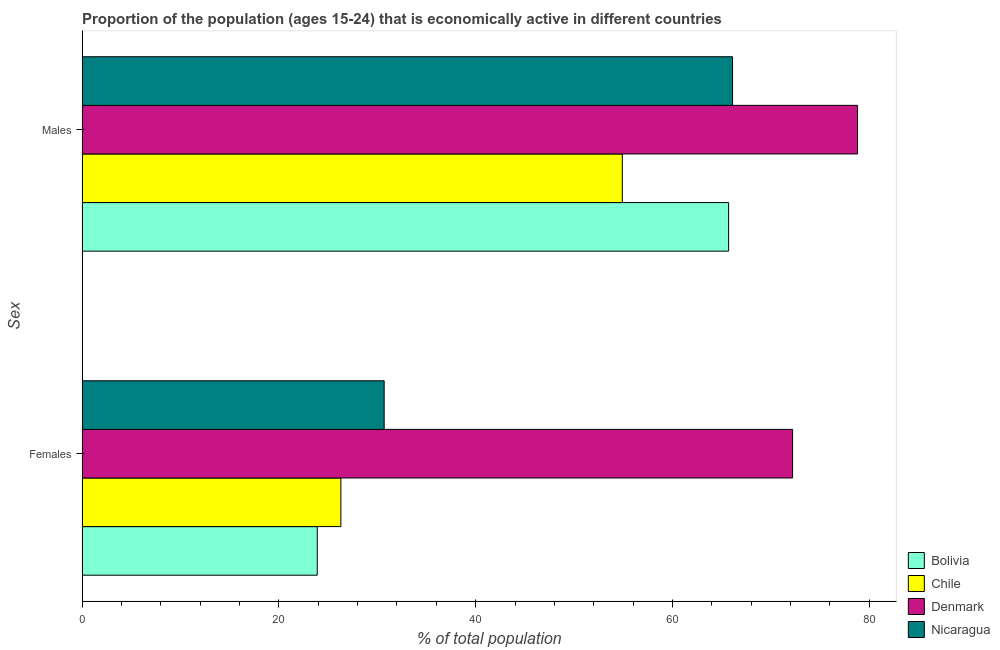How many different coloured bars are there?
Make the answer very short. 4. How many bars are there on the 2nd tick from the bottom?
Give a very brief answer. 4. What is the label of the 2nd group of bars from the top?
Give a very brief answer. Females. What is the percentage of economically active female population in Bolivia?
Your response must be concise. 23.9. Across all countries, what is the maximum percentage of economically active male population?
Your answer should be compact. 78.8. Across all countries, what is the minimum percentage of economically active female population?
Provide a succinct answer. 23.9. In which country was the percentage of economically active male population minimum?
Your answer should be compact. Chile. What is the total percentage of economically active female population in the graph?
Give a very brief answer. 153.1. What is the difference between the percentage of economically active male population in Denmark and that in Bolivia?
Offer a very short reply. 13.1. What is the difference between the percentage of economically active male population in Chile and the percentage of economically active female population in Nicaragua?
Your answer should be compact. 24.2. What is the average percentage of economically active female population per country?
Provide a succinct answer. 38.27. What is the difference between the percentage of economically active female population and percentage of economically active male population in Nicaragua?
Your answer should be compact. -35.4. In how many countries, is the percentage of economically active female population greater than 16 %?
Your answer should be very brief. 4. What is the ratio of the percentage of economically active female population in Bolivia to that in Nicaragua?
Make the answer very short. 0.78. In how many countries, is the percentage of economically active female population greater than the average percentage of economically active female population taken over all countries?
Give a very brief answer. 1. What does the 1st bar from the top in Females represents?
Your answer should be very brief. Nicaragua. Are all the bars in the graph horizontal?
Provide a short and direct response. Yes. How many countries are there in the graph?
Keep it short and to the point. 4. What is the difference between two consecutive major ticks on the X-axis?
Provide a succinct answer. 20. Are the values on the major ticks of X-axis written in scientific E-notation?
Offer a very short reply. No. Does the graph contain any zero values?
Give a very brief answer. No. Does the graph contain grids?
Make the answer very short. No. How are the legend labels stacked?
Your answer should be compact. Vertical. What is the title of the graph?
Offer a very short reply. Proportion of the population (ages 15-24) that is economically active in different countries. What is the label or title of the X-axis?
Give a very brief answer. % of total population. What is the label or title of the Y-axis?
Your response must be concise. Sex. What is the % of total population in Bolivia in Females?
Offer a very short reply. 23.9. What is the % of total population in Chile in Females?
Offer a very short reply. 26.3. What is the % of total population in Denmark in Females?
Keep it short and to the point. 72.2. What is the % of total population of Nicaragua in Females?
Keep it short and to the point. 30.7. What is the % of total population in Bolivia in Males?
Provide a succinct answer. 65.7. What is the % of total population of Chile in Males?
Your answer should be very brief. 54.9. What is the % of total population of Denmark in Males?
Keep it short and to the point. 78.8. What is the % of total population of Nicaragua in Males?
Keep it short and to the point. 66.1. Across all Sex, what is the maximum % of total population in Bolivia?
Offer a very short reply. 65.7. Across all Sex, what is the maximum % of total population of Chile?
Provide a short and direct response. 54.9. Across all Sex, what is the maximum % of total population in Denmark?
Your response must be concise. 78.8. Across all Sex, what is the maximum % of total population of Nicaragua?
Offer a terse response. 66.1. Across all Sex, what is the minimum % of total population of Bolivia?
Your response must be concise. 23.9. Across all Sex, what is the minimum % of total population in Chile?
Offer a very short reply. 26.3. Across all Sex, what is the minimum % of total population of Denmark?
Your answer should be compact. 72.2. Across all Sex, what is the minimum % of total population of Nicaragua?
Provide a succinct answer. 30.7. What is the total % of total population in Bolivia in the graph?
Provide a short and direct response. 89.6. What is the total % of total population in Chile in the graph?
Your response must be concise. 81.2. What is the total % of total population of Denmark in the graph?
Ensure brevity in your answer.  151. What is the total % of total population in Nicaragua in the graph?
Offer a very short reply. 96.8. What is the difference between the % of total population in Bolivia in Females and that in Males?
Keep it short and to the point. -41.8. What is the difference between the % of total population in Chile in Females and that in Males?
Offer a terse response. -28.6. What is the difference between the % of total population of Nicaragua in Females and that in Males?
Your response must be concise. -35.4. What is the difference between the % of total population in Bolivia in Females and the % of total population in Chile in Males?
Ensure brevity in your answer.  -31. What is the difference between the % of total population in Bolivia in Females and the % of total population in Denmark in Males?
Give a very brief answer. -54.9. What is the difference between the % of total population of Bolivia in Females and the % of total population of Nicaragua in Males?
Your response must be concise. -42.2. What is the difference between the % of total population of Chile in Females and the % of total population of Denmark in Males?
Offer a terse response. -52.5. What is the difference between the % of total population in Chile in Females and the % of total population in Nicaragua in Males?
Offer a terse response. -39.8. What is the average % of total population of Bolivia per Sex?
Provide a short and direct response. 44.8. What is the average % of total population of Chile per Sex?
Offer a very short reply. 40.6. What is the average % of total population of Denmark per Sex?
Your response must be concise. 75.5. What is the average % of total population in Nicaragua per Sex?
Keep it short and to the point. 48.4. What is the difference between the % of total population in Bolivia and % of total population in Chile in Females?
Provide a succinct answer. -2.4. What is the difference between the % of total population in Bolivia and % of total population in Denmark in Females?
Your response must be concise. -48.3. What is the difference between the % of total population in Chile and % of total population in Denmark in Females?
Keep it short and to the point. -45.9. What is the difference between the % of total population of Denmark and % of total population of Nicaragua in Females?
Give a very brief answer. 41.5. What is the difference between the % of total population in Bolivia and % of total population in Chile in Males?
Provide a short and direct response. 10.8. What is the difference between the % of total population in Bolivia and % of total population in Denmark in Males?
Ensure brevity in your answer.  -13.1. What is the difference between the % of total population of Bolivia and % of total population of Nicaragua in Males?
Offer a terse response. -0.4. What is the difference between the % of total population in Chile and % of total population in Denmark in Males?
Your response must be concise. -23.9. What is the difference between the % of total population in Chile and % of total population in Nicaragua in Males?
Your answer should be compact. -11.2. What is the difference between the % of total population of Denmark and % of total population of Nicaragua in Males?
Give a very brief answer. 12.7. What is the ratio of the % of total population of Bolivia in Females to that in Males?
Provide a succinct answer. 0.36. What is the ratio of the % of total population of Chile in Females to that in Males?
Your response must be concise. 0.48. What is the ratio of the % of total population of Denmark in Females to that in Males?
Offer a terse response. 0.92. What is the ratio of the % of total population in Nicaragua in Females to that in Males?
Offer a terse response. 0.46. What is the difference between the highest and the second highest % of total population in Bolivia?
Offer a very short reply. 41.8. What is the difference between the highest and the second highest % of total population of Chile?
Provide a short and direct response. 28.6. What is the difference between the highest and the second highest % of total population of Denmark?
Give a very brief answer. 6.6. What is the difference between the highest and the second highest % of total population of Nicaragua?
Keep it short and to the point. 35.4. What is the difference between the highest and the lowest % of total population in Bolivia?
Ensure brevity in your answer.  41.8. What is the difference between the highest and the lowest % of total population in Chile?
Your answer should be very brief. 28.6. What is the difference between the highest and the lowest % of total population in Nicaragua?
Give a very brief answer. 35.4. 